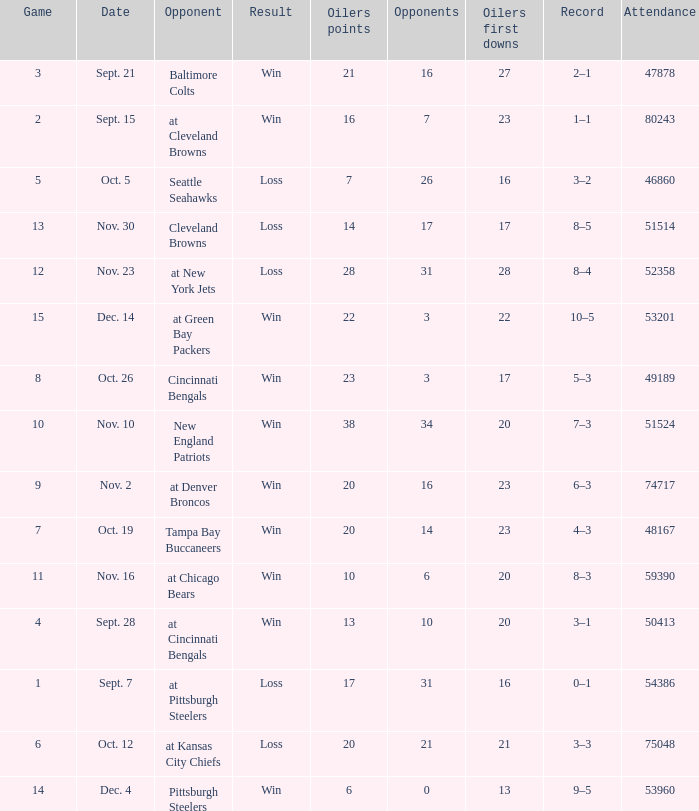What was the total opponents points for the game were the Oilers scored 21? 16.0. 